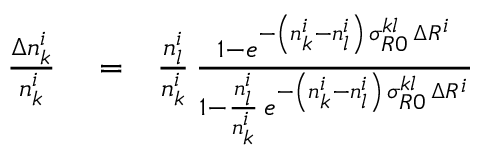Convert formula to latex. <formula><loc_0><loc_0><loc_500><loc_500>\begin{array} { r l r } { \frac { \Delta n _ { k } ^ { i } } { n _ { k } ^ { i } } } & = } & { \frac { n _ { l } ^ { i } } { n _ { k } ^ { i } } \, \frac { 1 - e ^ { - \left ( n _ { k } ^ { i } - n _ { l } ^ { i } \right ) \, \sigma _ { R 0 } ^ { k l } \, \Delta R ^ { i } } } { 1 - \frac { n _ { l } ^ { i } } { n _ { k } ^ { i } } \, e ^ { - \left ( n _ { k } ^ { i } - n _ { l } ^ { i } \right ) \, \sigma _ { R 0 } ^ { k l } \, \Delta R ^ { i } } } } \end{array}</formula> 